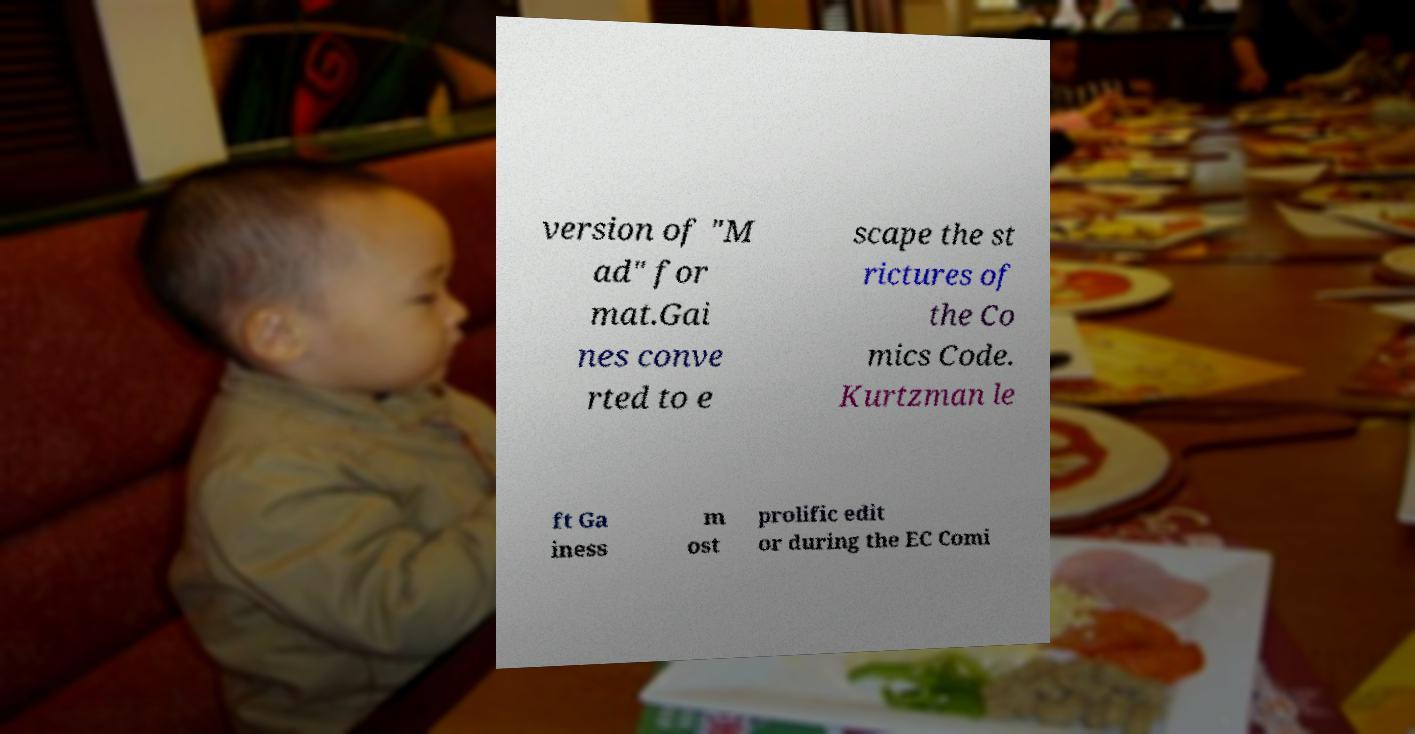Could you assist in decoding the text presented in this image and type it out clearly? version of "M ad" for mat.Gai nes conve rted to e scape the st rictures of the Co mics Code. Kurtzman le ft Ga iness m ost prolific edit or during the EC Comi 